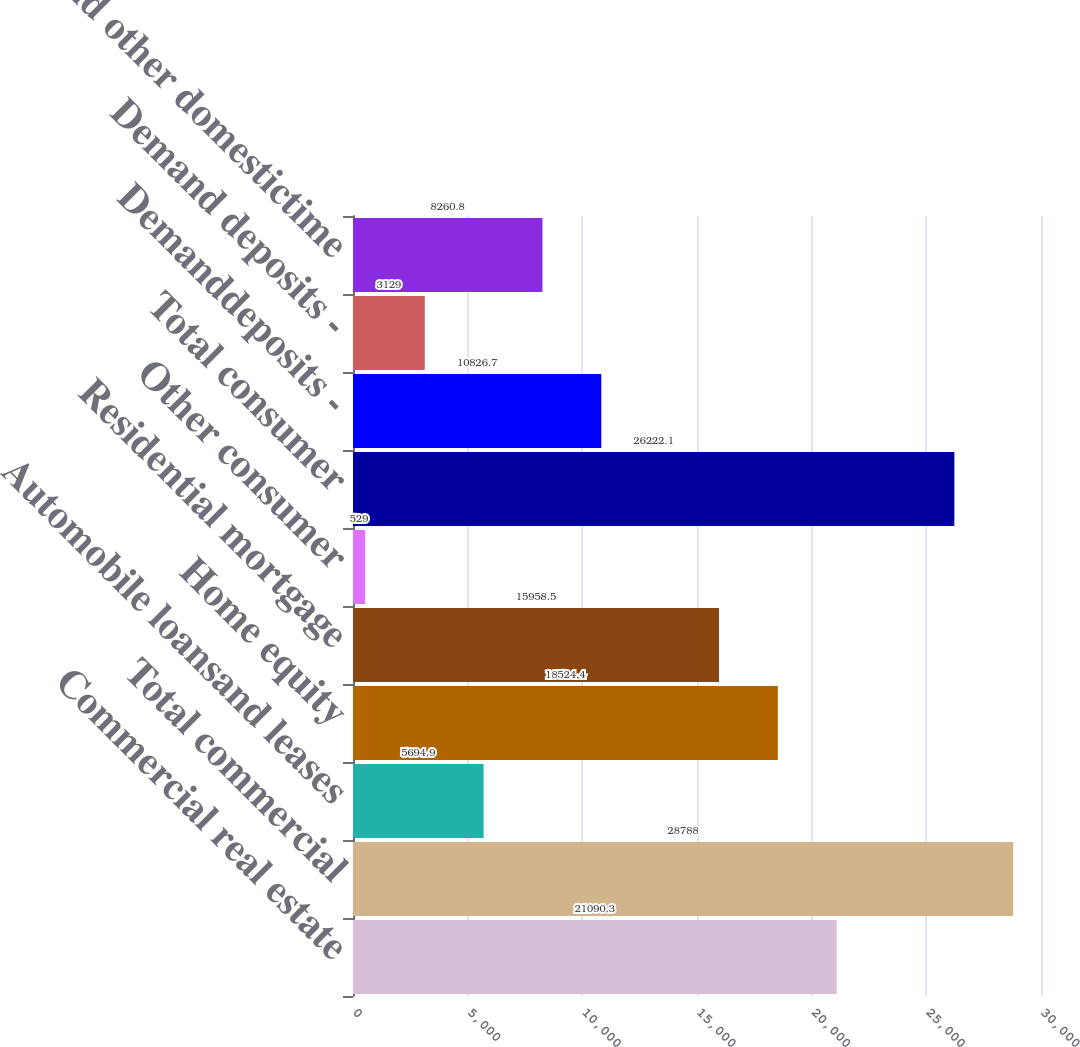<chart> <loc_0><loc_0><loc_500><loc_500><bar_chart><fcel>Commercial real estate<fcel>Total commercial<fcel>Automobile loansand leases<fcel>Home equity<fcel>Residential mortgage<fcel>Other consumer<fcel>Total consumer<fcel>Demanddeposits -<fcel>Demand deposits -<fcel>Savingsand other domestictime<nl><fcel>21090.3<fcel>28788<fcel>5694.9<fcel>18524.4<fcel>15958.5<fcel>529<fcel>26222.1<fcel>10826.7<fcel>3129<fcel>8260.8<nl></chart> 